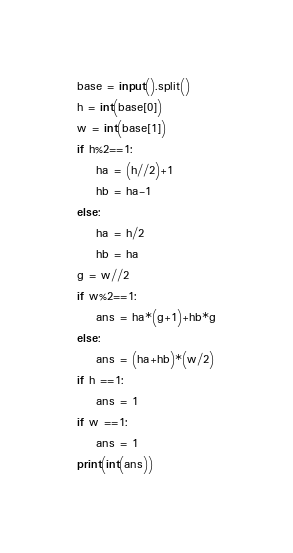<code> <loc_0><loc_0><loc_500><loc_500><_Python_>base = input().split()
h = int(base[0])
w = int(base[1])
if h%2==1:
    ha = (h//2)+1
    hb = ha-1
else:
    ha = h/2
    hb = ha
g = w//2
if w%2==1:
    ans = ha*(g+1)+hb*g
else:
    ans = (ha+hb)*(w/2)
if h ==1:
    ans = 1
if w ==1:
    ans = 1
print(int(ans))</code> 